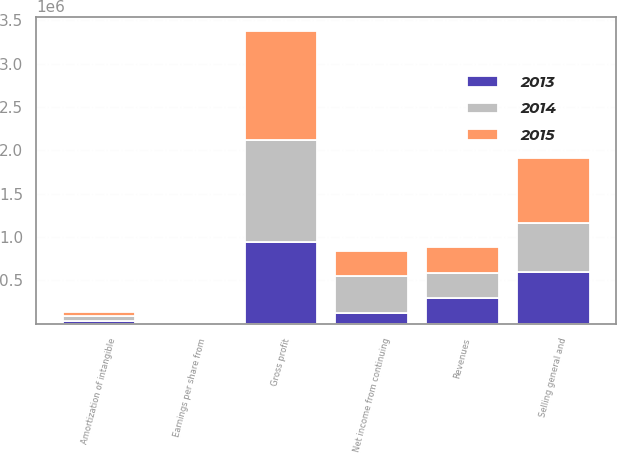Convert chart to OTSL. <chart><loc_0><loc_0><loc_500><loc_500><stacked_bar_chart><ecel><fcel>Revenues<fcel>Gross profit<fcel>Selling general and<fcel>Amortization of intangible<fcel>Net income from continuing<fcel>Earnings per share from<nl><fcel>2013<fcel>294588<fcel>939452<fcel>600057<fcel>36479<fcel>124550<fcel>0.64<nl><fcel>2015<fcel>294588<fcel>1.24883e+06<fcel>745321<fcel>47777<fcel>285404<fcel>1.28<nl><fcel>2014<fcel>294588<fcel>1.18569e+06<fcel>563877<fcel>50755<fcel>432011<fcel>1.95<nl></chart> 